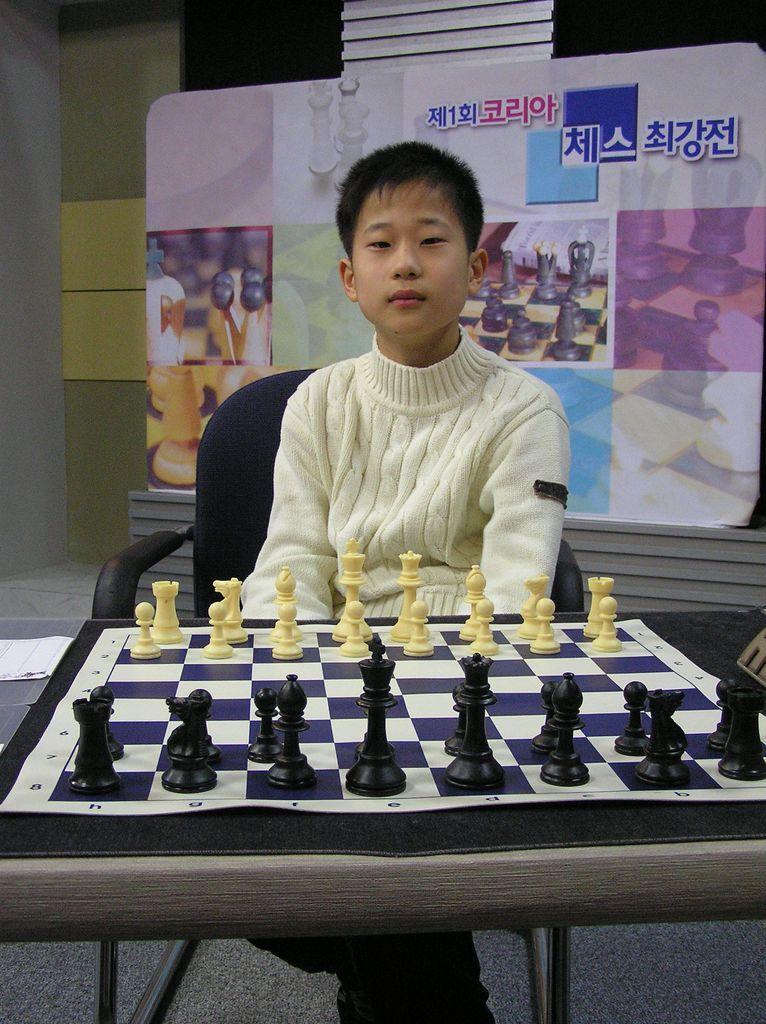Please provide a concise description of this image. In this image there is one kid sitting in a chair as we can see in the middle of this image. There is a chess board in the bottom of this image and there is a wall in the background. There are some pictures attached to the wall. 